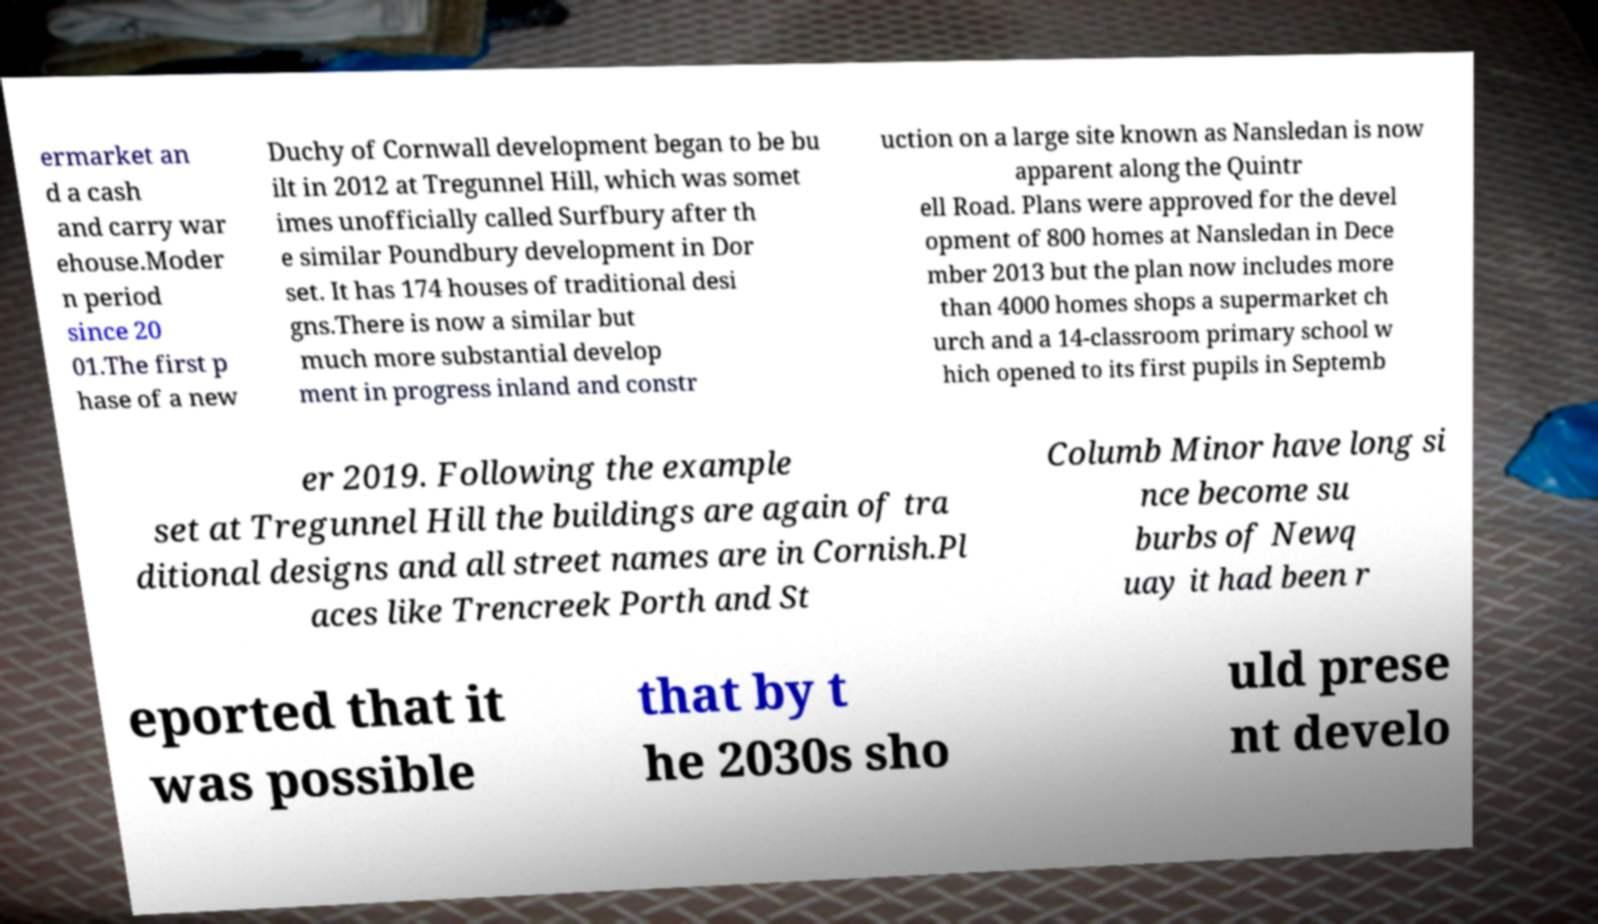Could you assist in decoding the text presented in this image and type it out clearly? ermarket an d a cash and carry war ehouse.Moder n period since 20 01.The first p hase of a new Duchy of Cornwall development began to be bu ilt in 2012 at Tregunnel Hill, which was somet imes unofficially called Surfbury after th e similar Poundbury development in Dor set. It has 174 houses of traditional desi gns.There is now a similar but much more substantial develop ment in progress inland and constr uction on a large site known as Nansledan is now apparent along the Quintr ell Road. Plans were approved for the devel opment of 800 homes at Nansledan in Dece mber 2013 but the plan now includes more than 4000 homes shops a supermarket ch urch and a 14-classroom primary school w hich opened to its first pupils in Septemb er 2019. Following the example set at Tregunnel Hill the buildings are again of tra ditional designs and all street names are in Cornish.Pl aces like Trencreek Porth and St Columb Minor have long si nce become su burbs of Newq uay it had been r eported that it was possible that by t he 2030s sho uld prese nt develo 